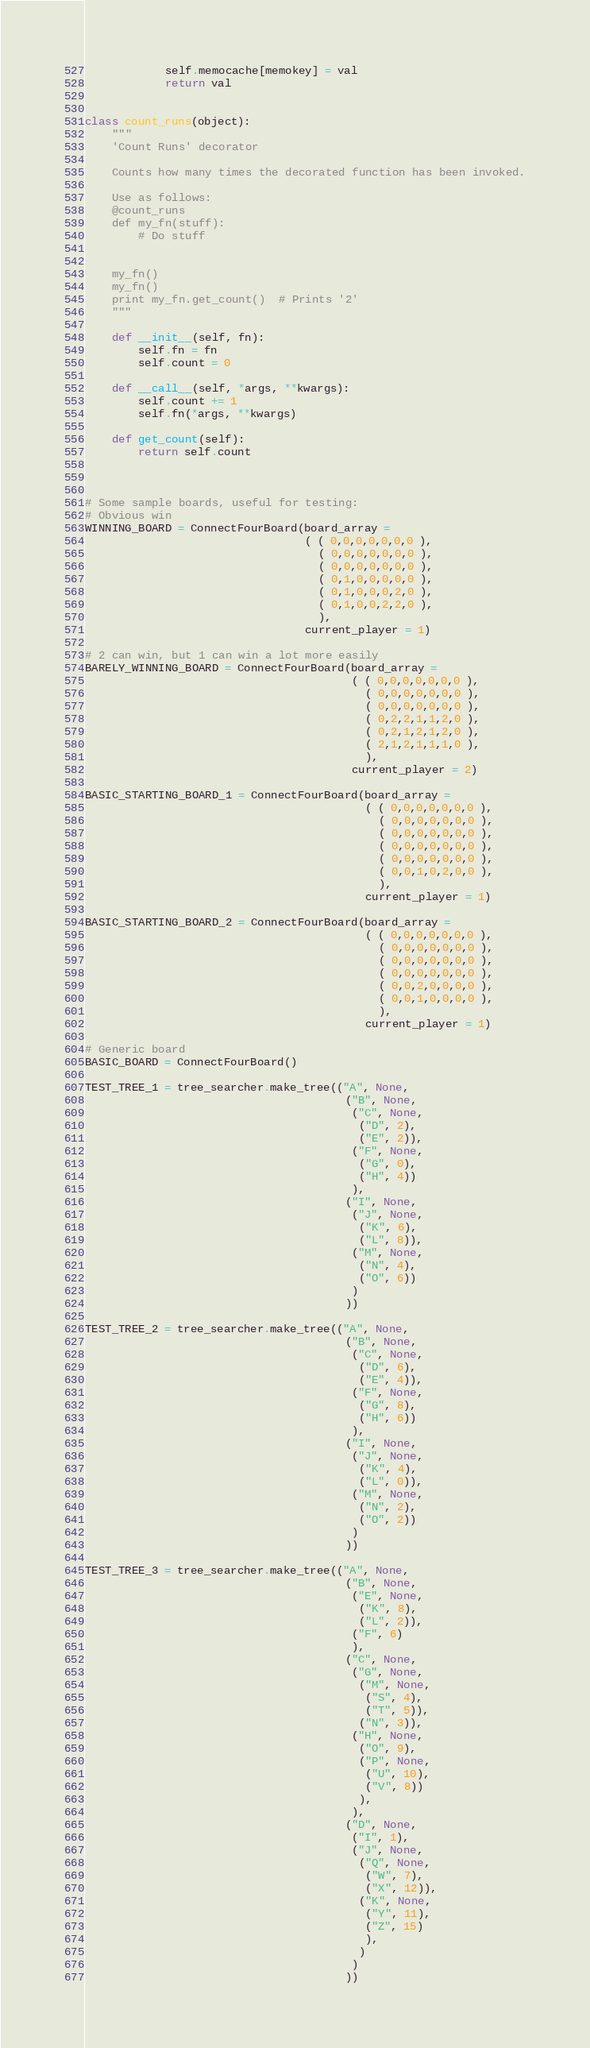<code> <loc_0><loc_0><loc_500><loc_500><_Python_>            self.memocache[memokey] = val
            return val


class count_runs(object):
    """
    'Count Runs' decorator

    Counts how many times the decorated function has been invoked.

    Use as follows:
    @count_runs
    def my_fn(stuff):
        # Do stuff


    my_fn()
    my_fn()
    print my_fn.get_count()  # Prints '2'
    """

    def __init__(self, fn):
        self.fn = fn
        self.count = 0

    def __call__(self, *args, **kwargs):
        self.count += 1
        self.fn(*args, **kwargs)

    def get_count(self):
        return self.count


    
# Some sample boards, useful for testing:
# Obvious win
WINNING_BOARD = ConnectFourBoard(board_array =
                                 ( ( 0,0,0,0,0,0,0 ),
                                   ( 0,0,0,0,0,0,0 ),
                                   ( 0,0,0,0,0,0,0 ),
                                   ( 0,1,0,0,0,0,0 ),
                                   ( 0,1,0,0,0,2,0 ),
                                   ( 0,1,0,0,2,2,0 ),
                                   ),
                                 current_player = 1)

# 2 can win, but 1 can win a lot more easily
BARELY_WINNING_BOARD = ConnectFourBoard(board_array =
                                        ( ( 0,0,0,0,0,0,0 ),
                                          ( 0,0,0,0,0,0,0 ),
                                          ( 0,0,0,0,0,0,0 ),
                                          ( 0,2,2,1,1,2,0 ),
                                          ( 0,2,1,2,1,2,0 ),
                                          ( 2,1,2,1,1,1,0 ),
                                          ),
                                        current_player = 2)

BASIC_STARTING_BOARD_1 = ConnectFourBoard(board_array =
                                          ( ( 0,0,0,0,0,0,0 ),
                                            ( 0,0,0,0,0,0,0 ),
                                            ( 0,0,0,0,0,0,0 ),
                                            ( 0,0,0,0,0,0,0 ),
                                            ( 0,0,0,0,0,0,0 ),
                                            ( 0,0,1,0,2,0,0 ),
                                            ),
                                          current_player = 1)

BASIC_STARTING_BOARD_2 = ConnectFourBoard(board_array =
                                          ( ( 0,0,0,0,0,0,0 ),
                                            ( 0,0,0,0,0,0,0 ),
                                            ( 0,0,0,0,0,0,0 ),
                                            ( 0,0,0,0,0,0,0 ),
                                            ( 0,0,2,0,0,0,0 ),
                                            ( 0,0,1,0,0,0,0 ),
                                            ),
                                          current_player = 1)

# Generic board
BASIC_BOARD = ConnectFourBoard()

TEST_TREE_1 = tree_searcher.make_tree(("A", None,
                                       ("B", None,
                                        ("C", None,
                                         ("D", 2),
                                         ("E", 2)),
                                        ("F", None,
                                         ("G", 0),
                                         ("H", 4))
                                        ),
                                       ("I", None,
                                        ("J", None,
                                         ("K", 6),
                                         ("L", 8)),
                                        ("M", None,
                                         ("N", 4),
                                         ("O", 6))
                                        )
                                       ))

TEST_TREE_2 = tree_searcher.make_tree(("A", None,
                                       ("B", None,
                                        ("C", None,
                                         ("D", 6),
                                         ("E", 4)),
                                        ("F", None,
                                         ("G", 8),
                                         ("H", 6))
                                        ),
                                       ("I", None,
                                        ("J", None,
                                         ("K", 4),
                                         ("L", 0)),
                                        ("M", None,
                                         ("N", 2),
                                         ("O", 2))
                                        )
                                       ))

TEST_TREE_3 = tree_searcher.make_tree(("A", None,
                                       ("B", None,
                                        ("E", None,
                                         ("K", 8),
                                         ("L", 2)),
                                        ("F", 6)
                                        ),
                                       ("C", None,
                                        ("G", None,
                                         ("M", None,
                                          ("S", 4),
                                          ("T", 5)),
                                         ("N", 3)),
                                        ("H", None,
                                         ("O", 9),
                                         ("P", None,
                                          ("U", 10),
                                          ("V", 8))
                                         ),
                                        ),
                                       ("D", None,
                                        ("I", 1),
                                        ("J", None,
                                         ("Q", None,
                                          ("W", 7),
                                          ("X", 12)),
                                         ("K", None,
                                          ("Y", 11),
                                          ("Z", 15)
                                          ),
                                         )
                                        )
                                       ))



</code> 